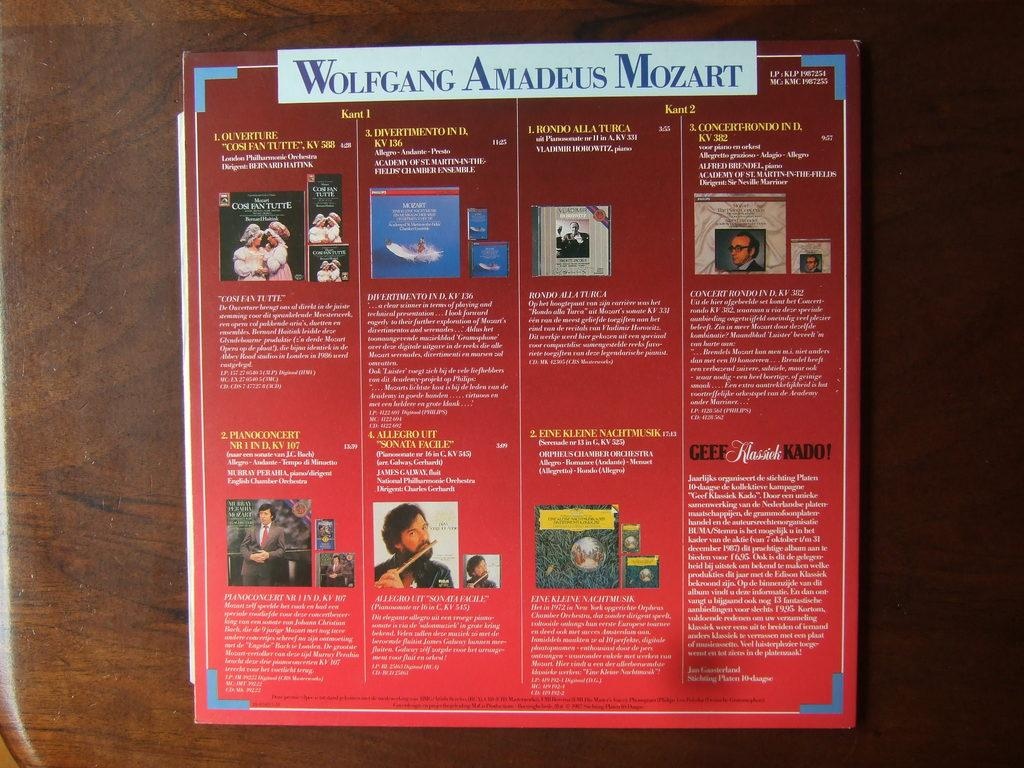<image>
Render a clear and concise summary of the photo. An informational brochure says Wolfgang Amadeus Mozart at the top. 